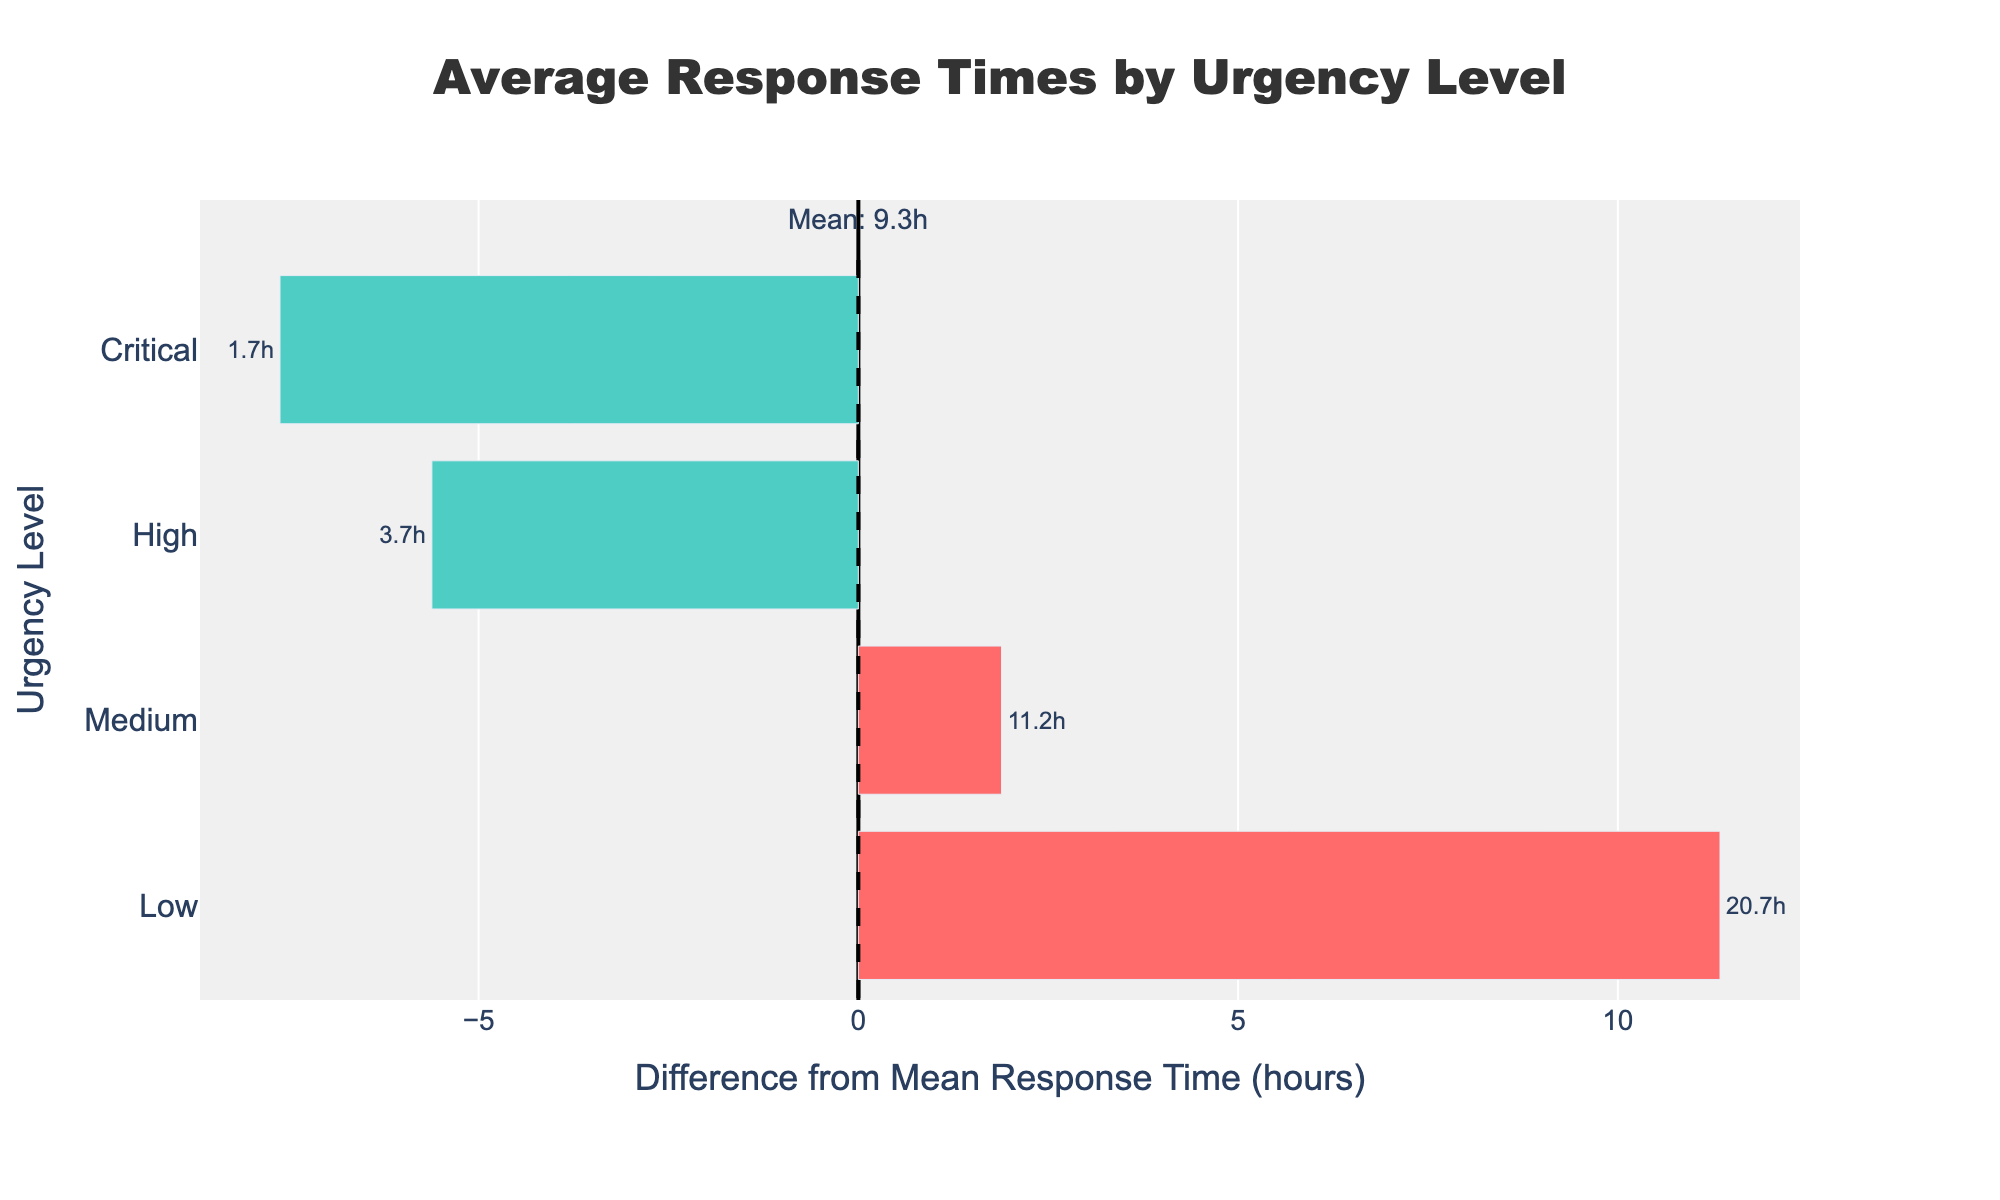What is the average response time for Critical urgency level? The figure shows that the average response time for Critical urgency level is displayed in the text annotation next to the bar
Answer: 1.7h Which urgency level has the highest average response time? By looking at the length and position of the bars, the urgency level with the highest average response time is on the top of the plot
Answer: Low What is the difference in average response time between High and Medium urgency levels? High urgency level has an average response time of approximately 3.7h and Medium has around 11.2h, so the difference is 11.2 - 3.7
Answer: 7.5h Which urgency level has an average response time closest to the overall mean? The midpoint (vertical dashed line) represents the overall mean, and the bar closest to this line indicates the urgency level with the average response time closest to the overall mean
Answer: High How much higher than the overall mean is the average response time for Low urgency level? The overall mean response time is indicated above the vertical dashed line, and for Low urgency level, the difference from the mean is displayed in the chart as the distance of the bar from the center
Answer: 6.1h Which urgency level has the shortest average response time? By examining the bars in the chart, the shortest bar on the left represents the urgency level with the shortest average response time
Answer: Critical How does the average response time for Medium urgency level compare to that of Critical urgency level? Medium urgency level has a longer average response time than Critical, as its bar extends further to the right in the plot
Answer: Longer What is the range of average response times across all urgency levels displayed? The shortest average response time is 1.7h (Critical) and the longest is 20.1h (Low), so the range is 20.1 - 1.7
Answer: 18.4h How do the colors of the bars help in understanding the data? Colors indicate whether the average response time is above or below the overall mean, making it easy to distinguish and compare different urgency levels
Answer: Red indicates above and Green indicates below 